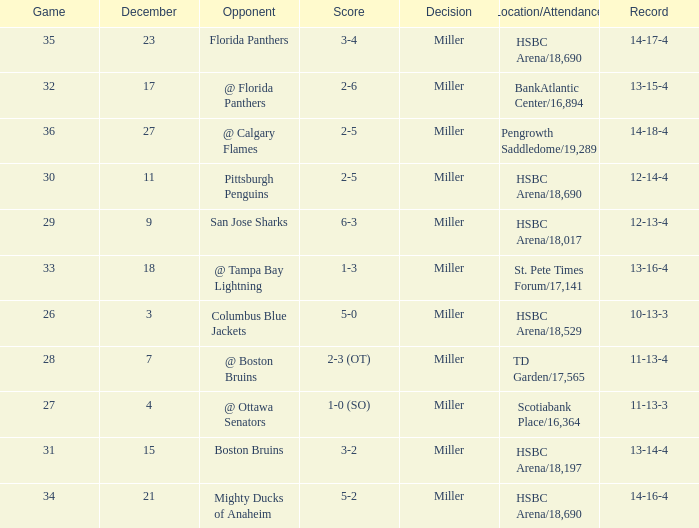Name the opponent for record 10-13-3 Columbus Blue Jackets. 